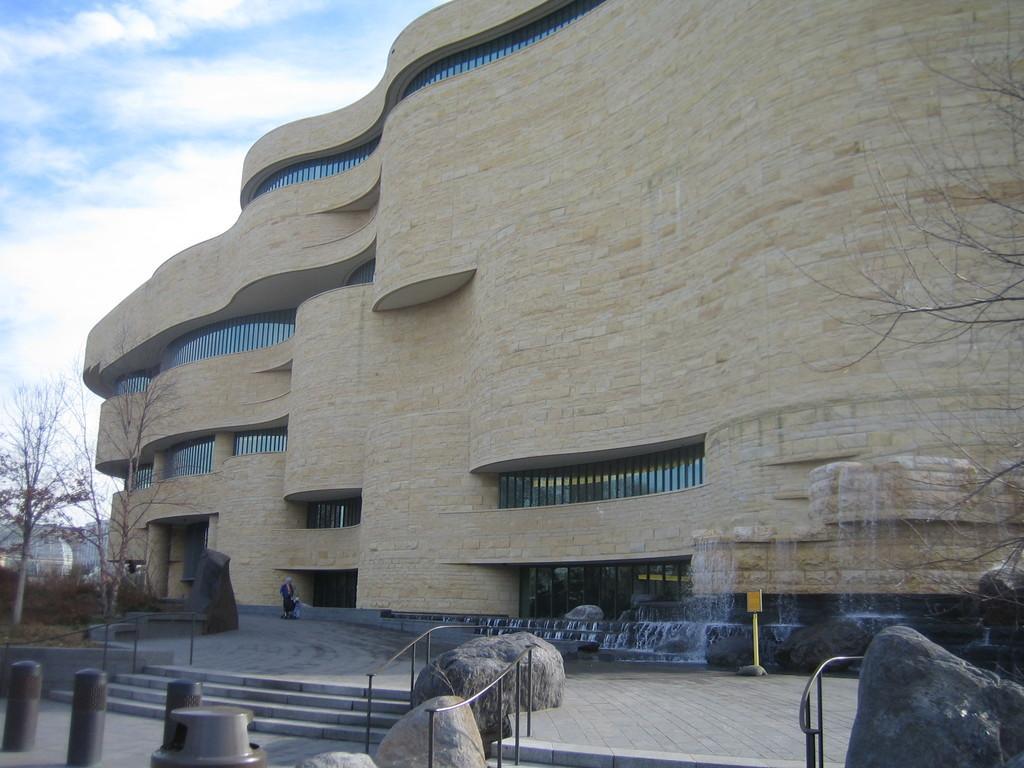Please provide a concise description of this image. In the picture we can see a huge building and near it we can see a path with some water falls and a board to the pole and we can see a person also standing near the building and we can also some steps, railing and besides it we can see some grass surface and dried trees on it and behind it we can see a sky. 